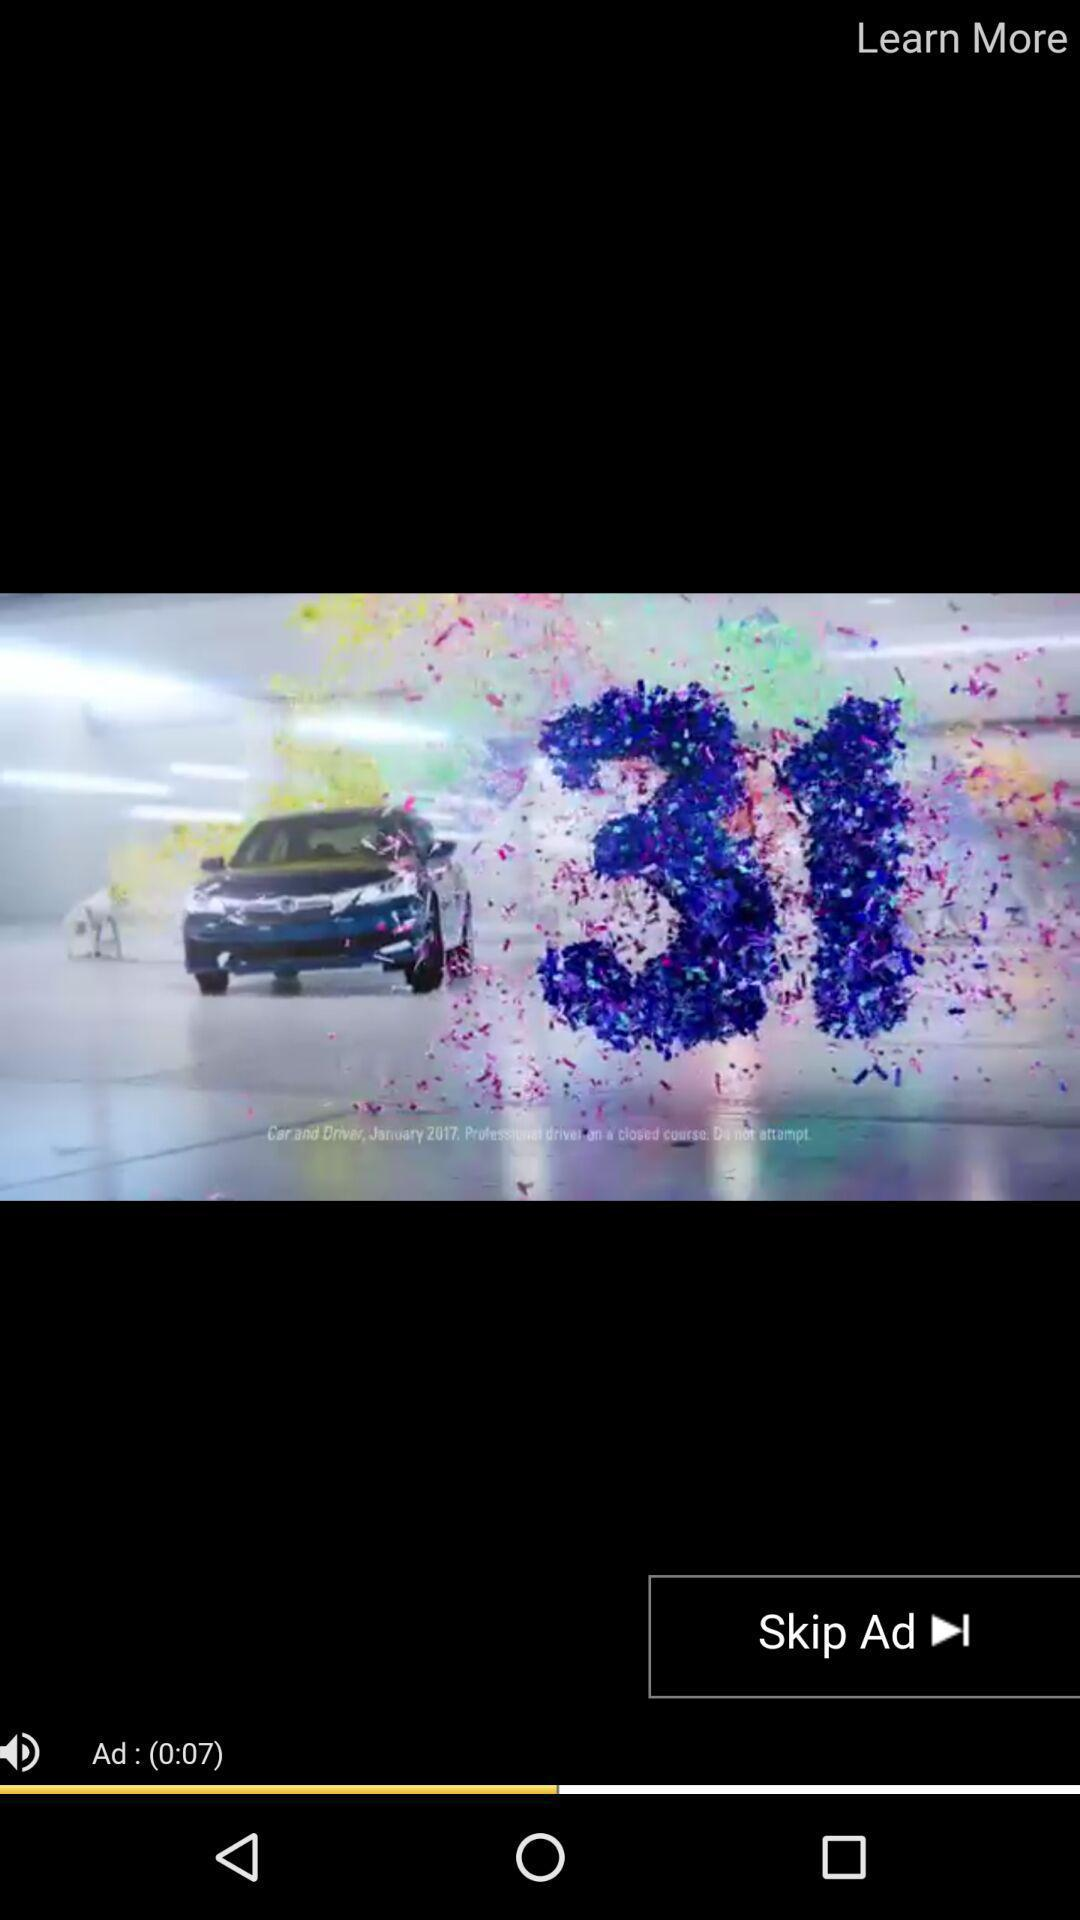What is the total duration of the ad?
Answer the question using a single word or phrase. 0:07 